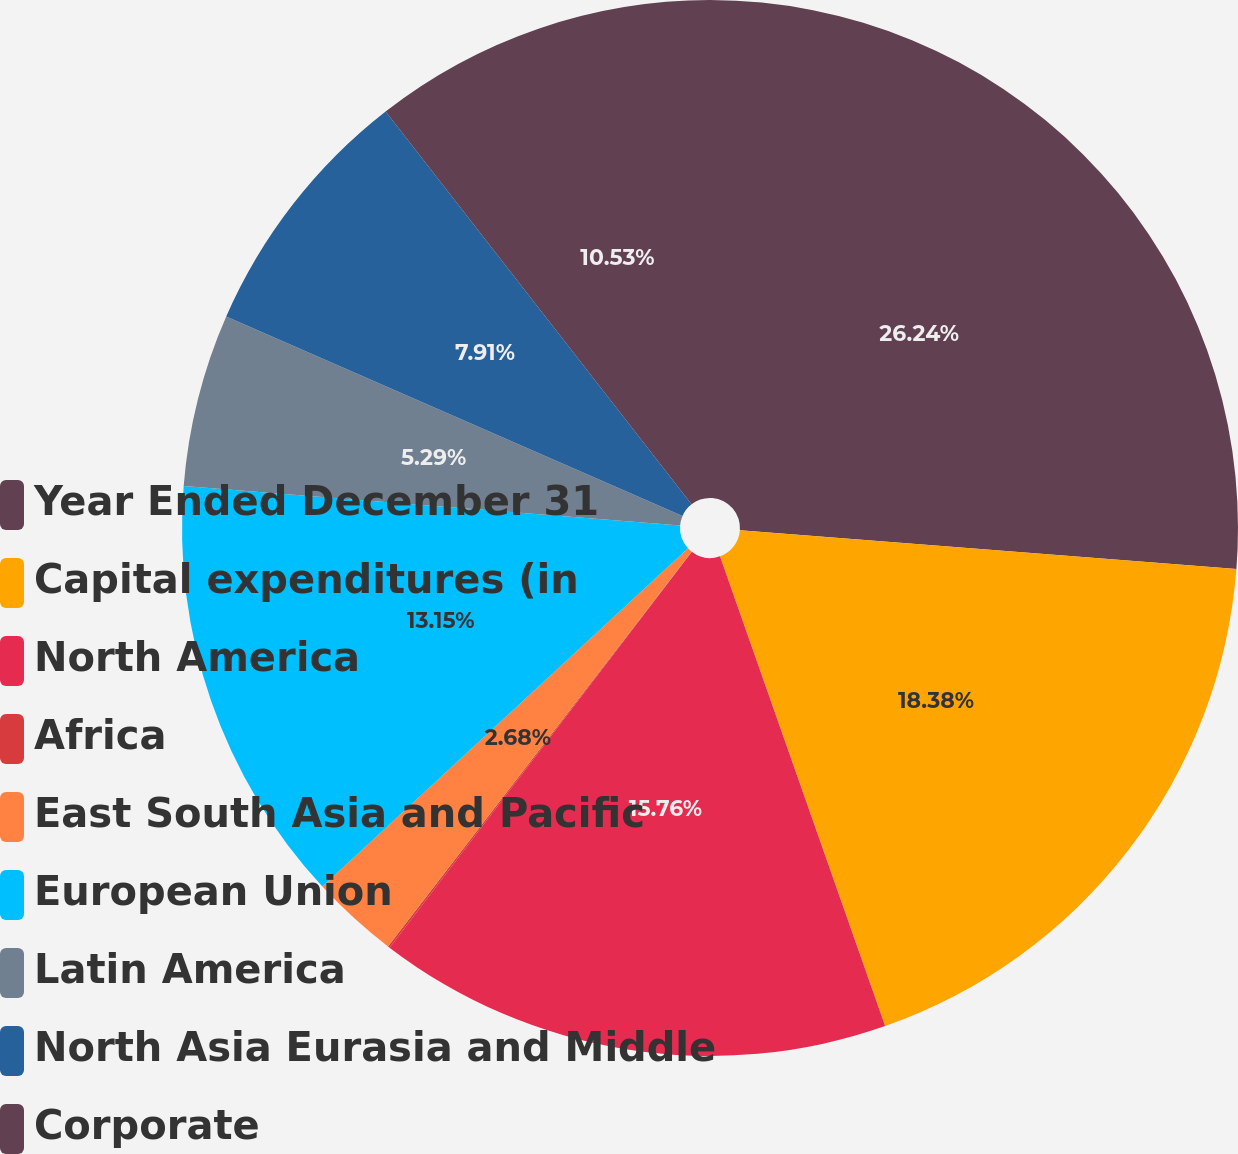Convert chart to OTSL. <chart><loc_0><loc_0><loc_500><loc_500><pie_chart><fcel>Year Ended December 31<fcel>Capital expenditures (in<fcel>North America<fcel>Africa<fcel>East South Asia and Pacific<fcel>European Union<fcel>Latin America<fcel>North Asia Eurasia and Middle<fcel>Corporate<nl><fcel>26.24%<fcel>18.38%<fcel>15.76%<fcel>0.06%<fcel>2.68%<fcel>13.15%<fcel>5.29%<fcel>7.91%<fcel>10.53%<nl></chart> 